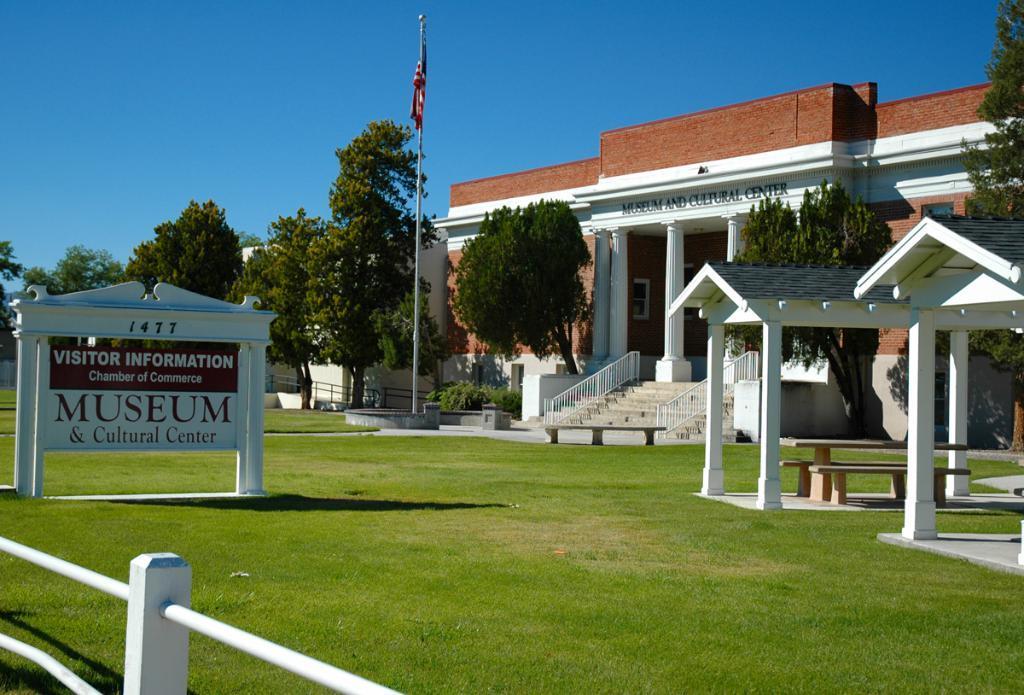Can you describe this image briefly? In this picture we can see grass at the bottom on the left side there is a board, we can see building in the background, there are some trees here, on the right side we can see two huts, there is a flag in the middle, we can see the sky at the top of the picture. 